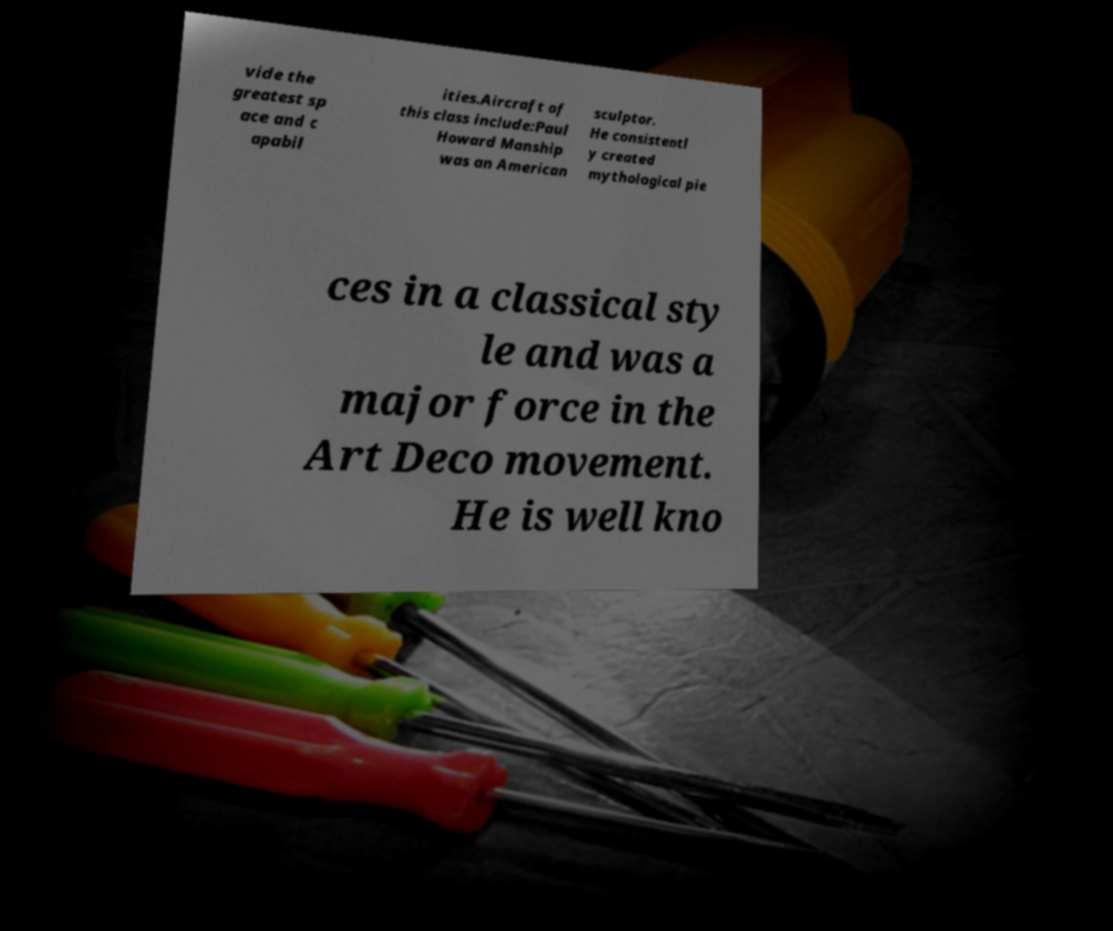Please identify and transcribe the text found in this image. vide the greatest sp ace and c apabil ities.Aircraft of this class include:Paul Howard Manship was an American sculptor. He consistentl y created mythological pie ces in a classical sty le and was a major force in the Art Deco movement. He is well kno 